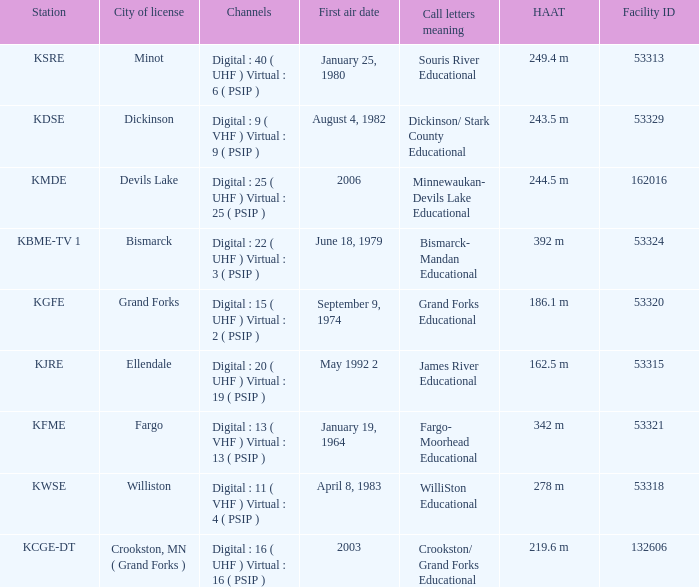What is the haat of devils lake 244.5 m. 